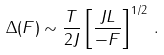Convert formula to latex. <formula><loc_0><loc_0><loc_500><loc_500>\Delta ( F ) \sim \frac { T } { 2 J } \left [ \frac { J L } { - F } \right ] ^ { 1 / 2 } \, .</formula> 